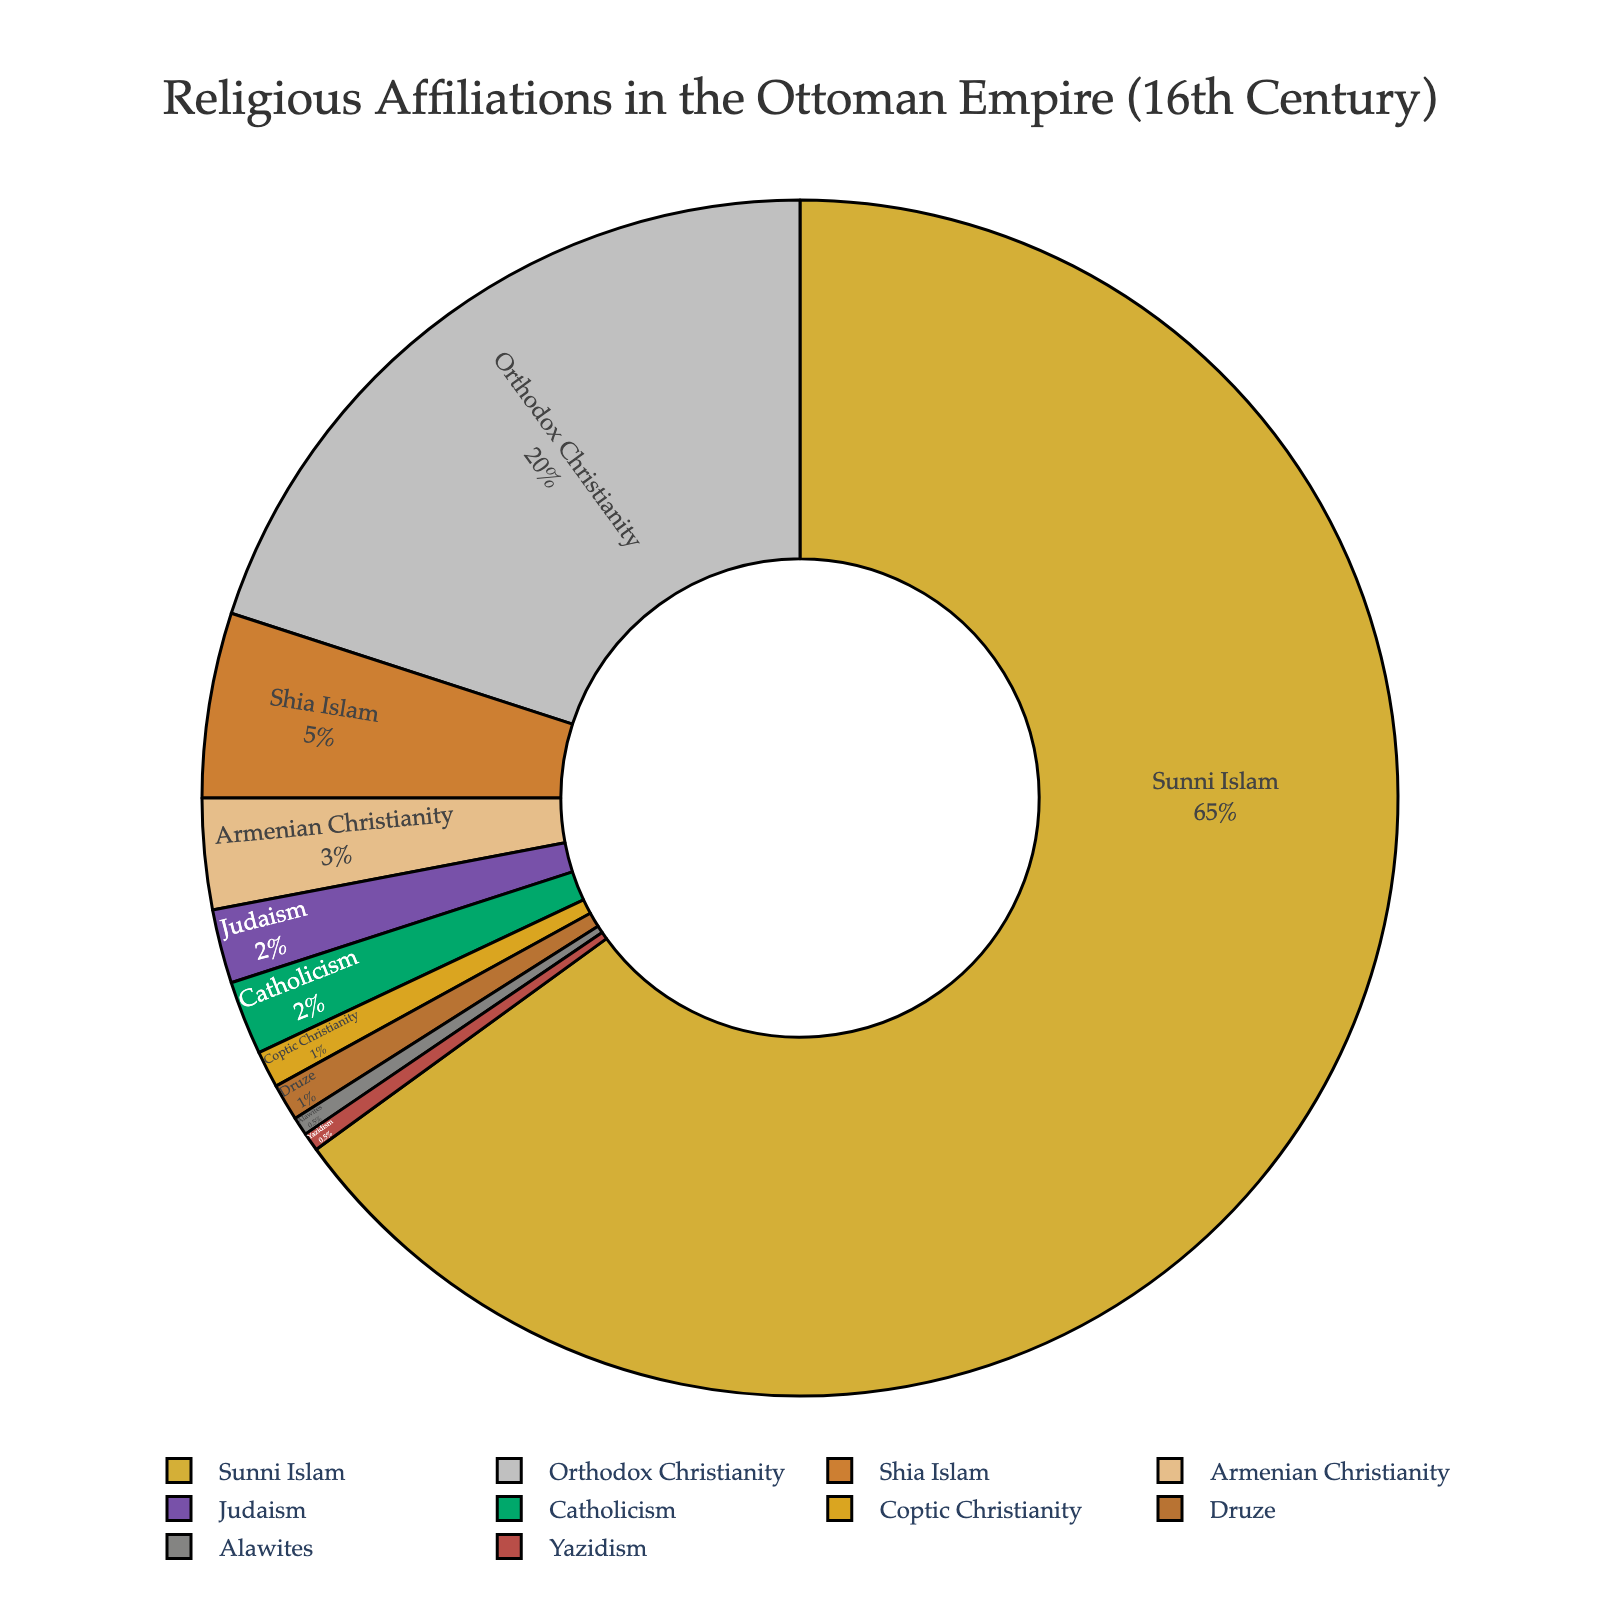What percentage of the religious affiliations in the Ottoman Empire at its peak was made up of Christian groups? Sum the percentages of Orthodox Christianity (20%), Armenian Christianity (3%), Catholicism (2%), and Coptic Christianity (1%). Therefore, 20 + 3 + 2 + 1 = 26%.
Answer: 26% How much larger is the percentage of Sunni Islam compared to Orthodox Christianity? Subtract the percentage of Orthodox Christianity (20%) from the percentage of Sunni Islam (65%). Therefore, 65 - 20 = 45%.
Answer: 45% What is the combined percentage of Shia Islam and Armenian Christianity? Sum the percentages of Shia Islam (5%) and Armenian Christianity (3%). Therefore, 5 + 3 = 8%.
Answer: 8% Which religious group has the smallest representation in the Ottoman Empire? Identify the religious group with the lowest percentage. Both Alawites and Yazidism have a percentage of 0.5% which is the smallest.
Answer: Alawites and Yazidism Which religious affiliations are less than 2% of the population? Identify religious groups with a percentage less than 2%. This includes Judaism (2%), Catholicism (2%), Coptic Christianity (1%), Druze (1%), Alawites (0.5%), and Yazidism (0.5%).
Answer: Coptic Christianity, Druze, Alawites, Yazidism Is the percentage of people who follow Judaism equal to or greater than the percentage of people who follow Armenian Christianity? Compare the percentage of Judaism (2%) to Armenian Christianity (3%). 2% is less than 3%.
Answer: No What's the difference in percentage between the second and third largest religious groups? Identify the second and third largest groups, which are Orthodox Christianity (20%) and Shia Islam (5%) respectively. Subtract the percentage of Shia Islam from Orthodox Christianity. Therefore, 20 - 5 = 15%.
Answer: 15% Which religious group is represented by the color green in the pie chart? Identify the color associated with each religious group. From the color palette, green represents Judaism.
Answer: Judaism 